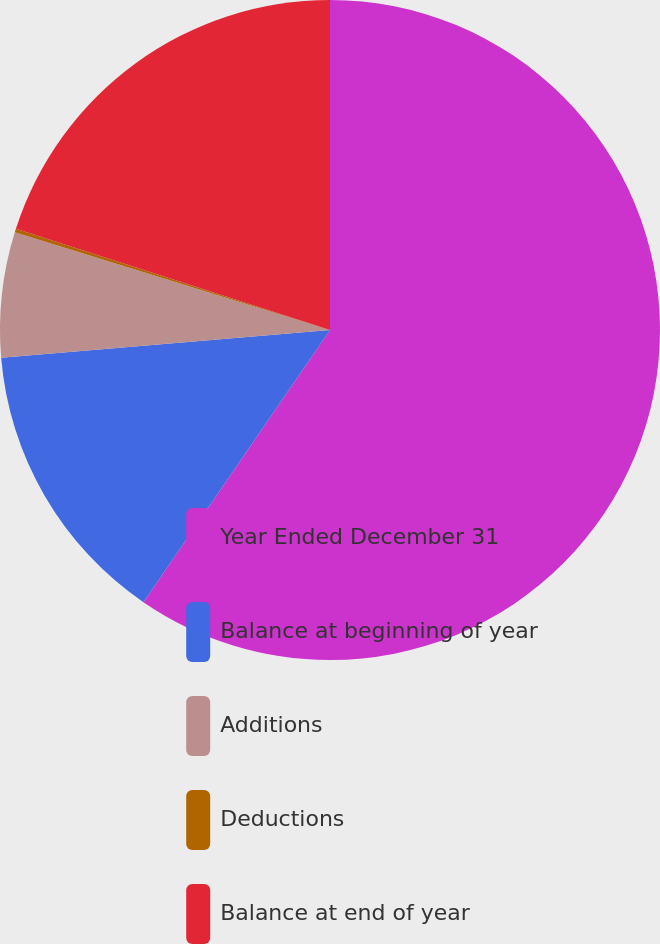<chart> <loc_0><loc_0><loc_500><loc_500><pie_chart><fcel>Year Ended December 31<fcel>Balance at beginning of year<fcel>Additions<fcel>Deductions<fcel>Balance at end of year<nl><fcel>59.57%<fcel>14.1%<fcel>6.12%<fcel>0.18%<fcel>20.04%<nl></chart> 